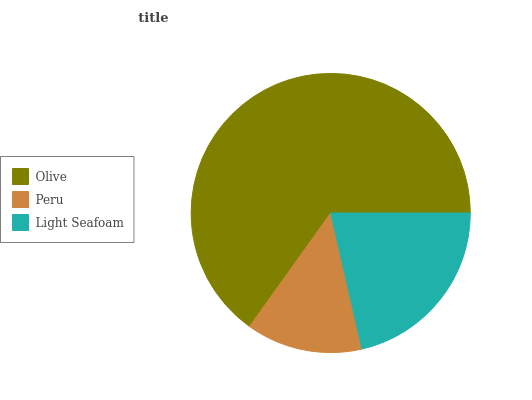Is Peru the minimum?
Answer yes or no. Yes. Is Olive the maximum?
Answer yes or no. Yes. Is Light Seafoam the minimum?
Answer yes or no. No. Is Light Seafoam the maximum?
Answer yes or no. No. Is Light Seafoam greater than Peru?
Answer yes or no. Yes. Is Peru less than Light Seafoam?
Answer yes or no. Yes. Is Peru greater than Light Seafoam?
Answer yes or no. No. Is Light Seafoam less than Peru?
Answer yes or no. No. Is Light Seafoam the high median?
Answer yes or no. Yes. Is Light Seafoam the low median?
Answer yes or no. Yes. Is Peru the high median?
Answer yes or no. No. Is Olive the low median?
Answer yes or no. No. 